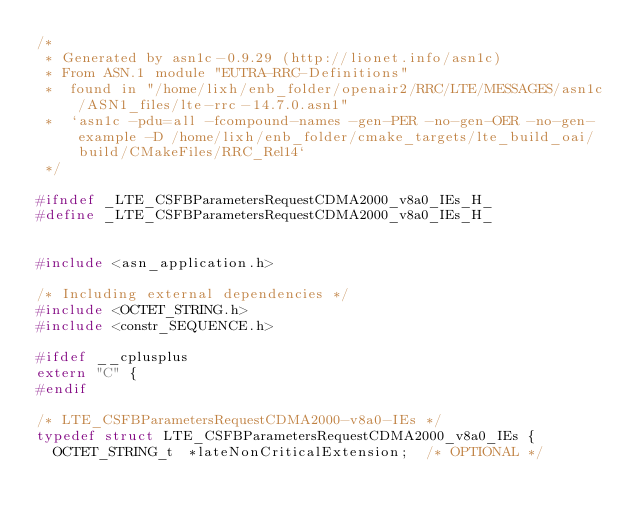Convert code to text. <code><loc_0><loc_0><loc_500><loc_500><_C_>/*
 * Generated by asn1c-0.9.29 (http://lionet.info/asn1c)
 * From ASN.1 module "EUTRA-RRC-Definitions"
 * 	found in "/home/lixh/enb_folder/openair2/RRC/LTE/MESSAGES/asn1c/ASN1_files/lte-rrc-14.7.0.asn1"
 * 	`asn1c -pdu=all -fcompound-names -gen-PER -no-gen-OER -no-gen-example -D /home/lixh/enb_folder/cmake_targets/lte_build_oai/build/CMakeFiles/RRC_Rel14`
 */

#ifndef	_LTE_CSFBParametersRequestCDMA2000_v8a0_IEs_H_
#define	_LTE_CSFBParametersRequestCDMA2000_v8a0_IEs_H_


#include <asn_application.h>

/* Including external dependencies */
#include <OCTET_STRING.h>
#include <constr_SEQUENCE.h>

#ifdef __cplusplus
extern "C" {
#endif

/* LTE_CSFBParametersRequestCDMA2000-v8a0-IEs */
typedef struct LTE_CSFBParametersRequestCDMA2000_v8a0_IEs {
	OCTET_STRING_t	*lateNonCriticalExtension;	/* OPTIONAL */</code> 